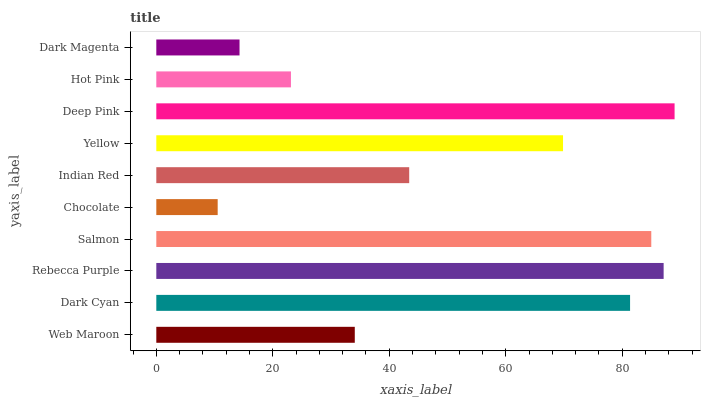Is Chocolate the minimum?
Answer yes or no. Yes. Is Deep Pink the maximum?
Answer yes or no. Yes. Is Dark Cyan the minimum?
Answer yes or no. No. Is Dark Cyan the maximum?
Answer yes or no. No. Is Dark Cyan greater than Web Maroon?
Answer yes or no. Yes. Is Web Maroon less than Dark Cyan?
Answer yes or no. Yes. Is Web Maroon greater than Dark Cyan?
Answer yes or no. No. Is Dark Cyan less than Web Maroon?
Answer yes or no. No. Is Yellow the high median?
Answer yes or no. Yes. Is Indian Red the low median?
Answer yes or no. Yes. Is Rebecca Purple the high median?
Answer yes or no. No. Is Yellow the low median?
Answer yes or no. No. 